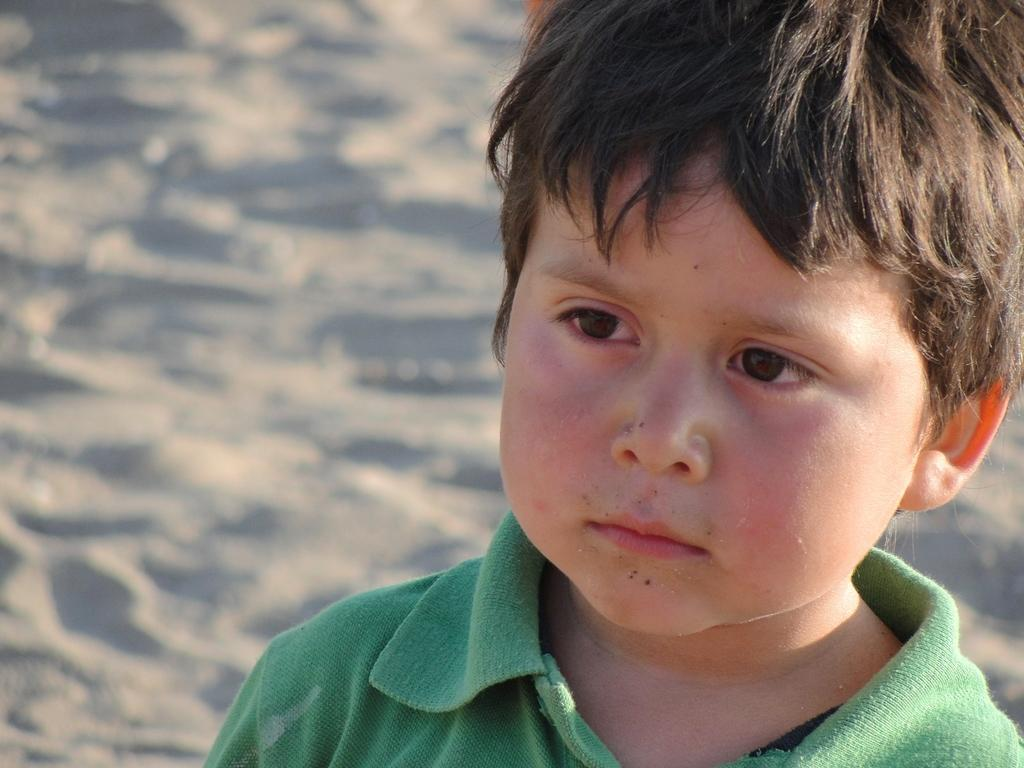Who is the main subject in the image? There is a boy in the image. What is the boy wearing? The boy is wearing a green t-shirt. Can you describe the background of the image? The background of the image is blurry. What type of patch can be seen on the boy's t-shirt in the image? There is no patch visible on the boy's t-shirt in the image. What religion does the boy in the image practice? There is no information about the boy's religion in the image. 